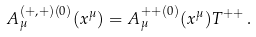<formula> <loc_0><loc_0><loc_500><loc_500>A _ { \mu } ^ { ( + , + ) ( 0 ) } ( x ^ { \mu } ) = A _ { \mu } ^ { + + ( 0 ) } ( x ^ { \mu } ) T ^ { + + } \, .</formula> 